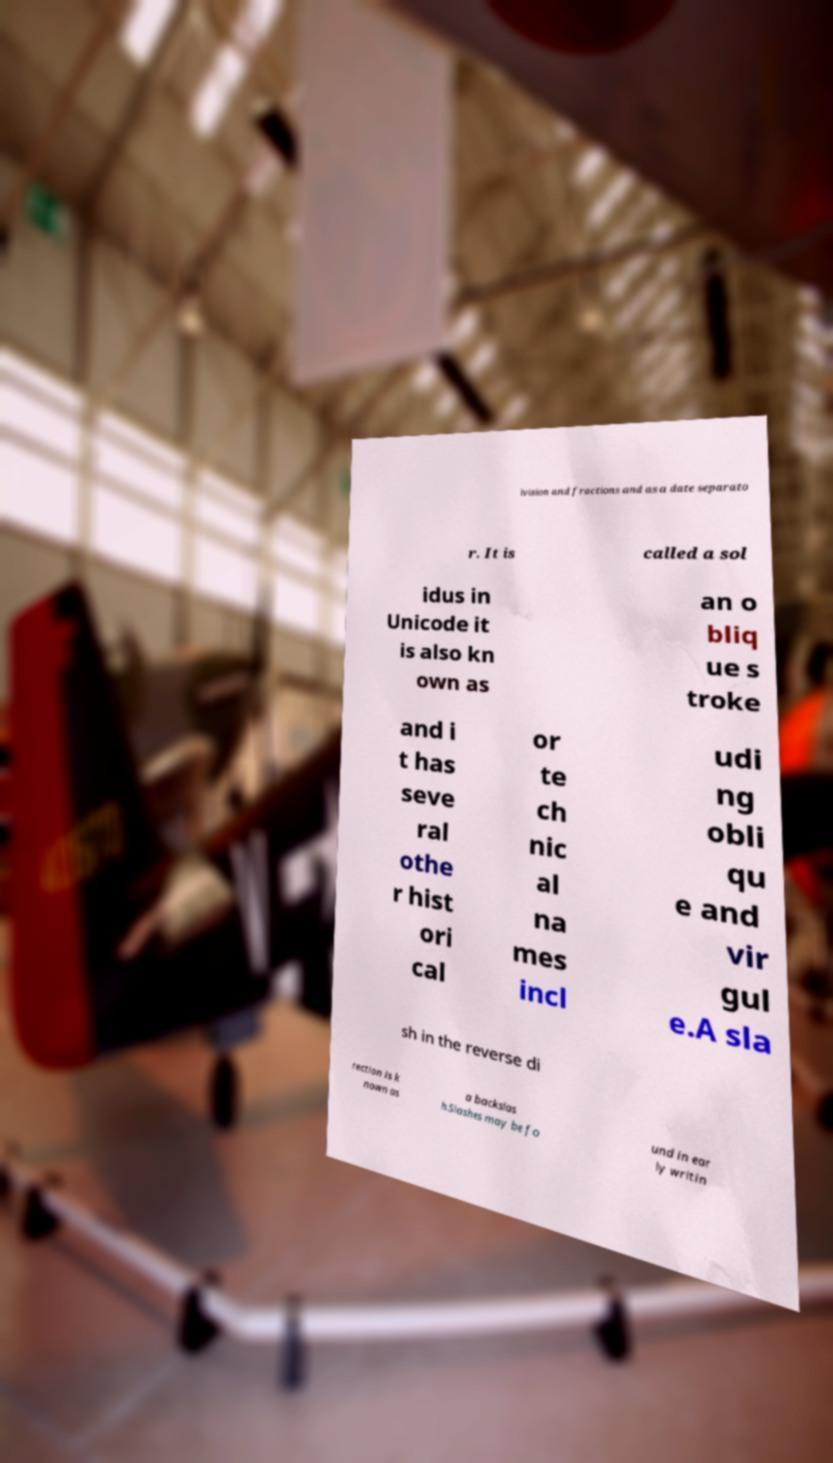What messages or text are displayed in this image? I need them in a readable, typed format. ivision and fractions and as a date separato r. It is called a sol idus in Unicode it is also kn own as an o bliq ue s troke and i t has seve ral othe r hist ori cal or te ch nic al na mes incl udi ng obli qu e and vir gul e.A sla sh in the reverse di rection is k nown as a backslas h.Slashes may be fo und in ear ly writin 